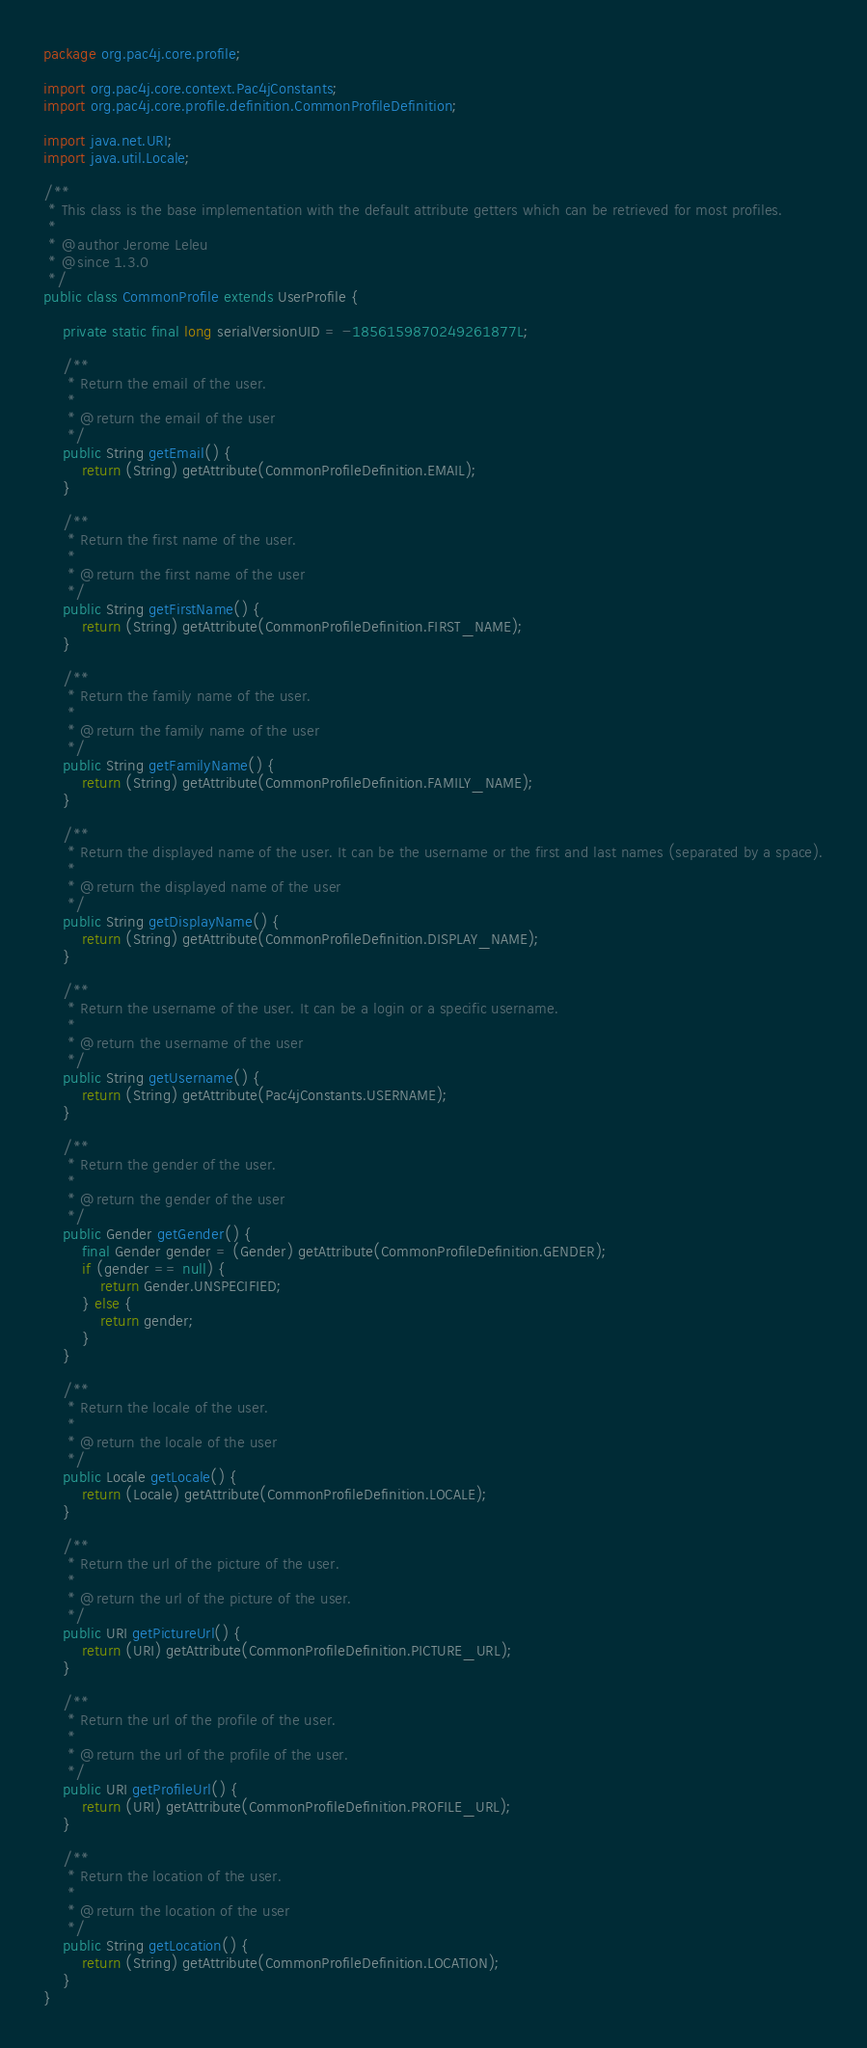<code> <loc_0><loc_0><loc_500><loc_500><_Java_>package org.pac4j.core.profile;

import org.pac4j.core.context.Pac4jConstants;
import org.pac4j.core.profile.definition.CommonProfileDefinition;

import java.net.URI;
import java.util.Locale;

/**
 * This class is the base implementation with the default attribute getters which can be retrieved for most profiles.
 *
 * @author Jerome Leleu
 * @since 1.3.0
 */
public class CommonProfile extends UserProfile {

    private static final long serialVersionUID = -1856159870249261877L;

    /**
     * Return the email of the user.
     *
     * @return the email of the user
     */
    public String getEmail() {
        return (String) getAttribute(CommonProfileDefinition.EMAIL);
    }

    /**
     * Return the first name of the user.
     *
     * @return the first name of the user
     */
    public String getFirstName() {
        return (String) getAttribute(CommonProfileDefinition.FIRST_NAME);
    }

    /**
     * Return the family name of the user.
     *
     * @return the family name of the user
     */
    public String getFamilyName() {
        return (String) getAttribute(CommonProfileDefinition.FAMILY_NAME);
    }

    /**
     * Return the displayed name of the user. It can be the username or the first and last names (separated by a space).
     *
     * @return the displayed name of the user
     */
    public String getDisplayName() {
        return (String) getAttribute(CommonProfileDefinition.DISPLAY_NAME);
    }

    /**
     * Return the username of the user. It can be a login or a specific username.
     *
     * @return the username of the user
     */
    public String getUsername() {
        return (String) getAttribute(Pac4jConstants.USERNAME);
    }

    /**
     * Return the gender of the user.
     *
     * @return the gender of the user
     */
    public Gender getGender() {
        final Gender gender = (Gender) getAttribute(CommonProfileDefinition.GENDER);
        if (gender == null) {
            return Gender.UNSPECIFIED;
        } else {
            return gender;
        }
    }

    /**
     * Return the locale of the user.
     *
     * @return the locale of the user
     */
    public Locale getLocale() {
        return (Locale) getAttribute(CommonProfileDefinition.LOCALE);
    }

    /**
     * Return the url of the picture of the user.
     *
     * @return the url of the picture of the user.
     */
    public URI getPictureUrl() {
        return (URI) getAttribute(CommonProfileDefinition.PICTURE_URL);
    }

    /**
     * Return the url of the profile of the user.
     *
     * @return the url of the profile of the user.
     */
    public URI getProfileUrl() {
        return (URI) getAttribute(CommonProfileDefinition.PROFILE_URL);
    }

    /**
     * Return the location of the user.
     *
     * @return the location of the user
     */
    public String getLocation() {
        return (String) getAttribute(CommonProfileDefinition.LOCATION);
    }
}
</code> 